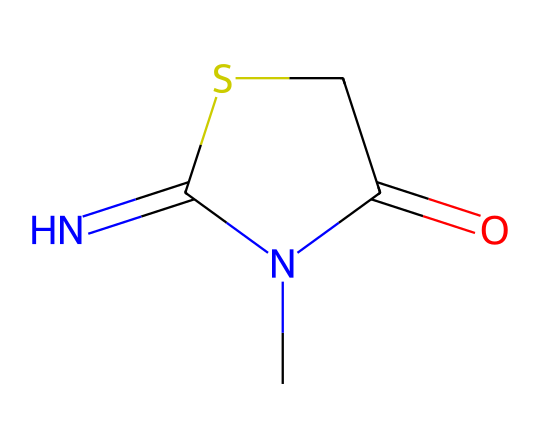What is the main functional group present in this chemical? The chemical structure shows a thiazole ring, indicated by the sulfur (S) atom and nitrogen (N) atom in the ring. The carbonyl group (C=O) is also observed, which confirms the presence of an amide functional group.
Answer: thiazole How many nitrogen atoms are in this structure? By analyzing the SMILES representation, I can count two nitrogen atoms (N) present in the structure. Each nitrogen is integral to the unique properties and reactions of the chemical.
Answer: 2 What type of bond connects the carbon to the nitrogen in the amide functional group? The bond connecting the carbon to the nitrogen in the amide group is a double bond, as indicated by the “C(=O)” part of the SMILES representation, showcasing a carbonyl group attached to nitrogen.
Answer: double bond What role does methylisothiazolinone primarily serve in film storage products? Methylisothiazolinone is known for its preservative properties, primarily preventing microbial growth, making it suitable for use in storage and preservation of film materials.
Answer: preservative How many total atoms are present in the entire molecule? By carefully counting each atom in the SMILES structure, I determine that there are a total of six atoms: two nitrogen (N), one sulfur (S), one carbonyl carbon (C), and two additional carbons from the thiazole structure.
Answer: 6 